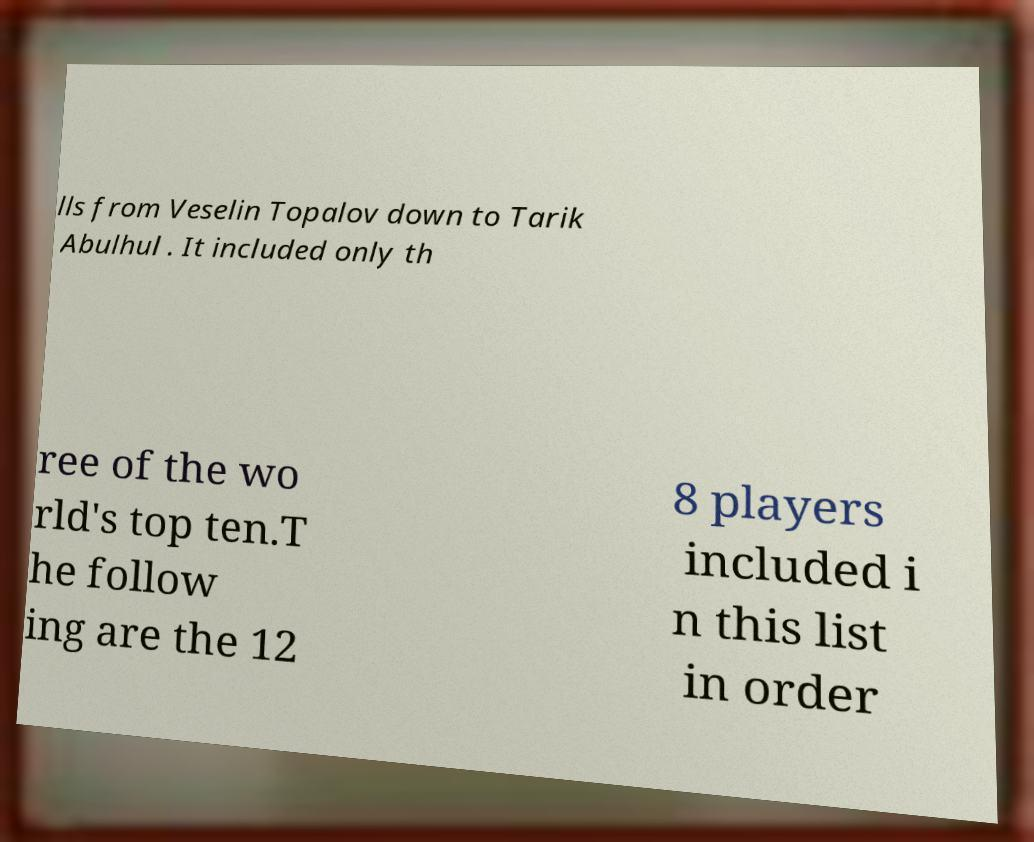Could you extract and type out the text from this image? lls from Veselin Topalov down to Tarik Abulhul . It included only th ree of the wo rld's top ten.T he follow ing are the 12 8 players included i n this list in order 